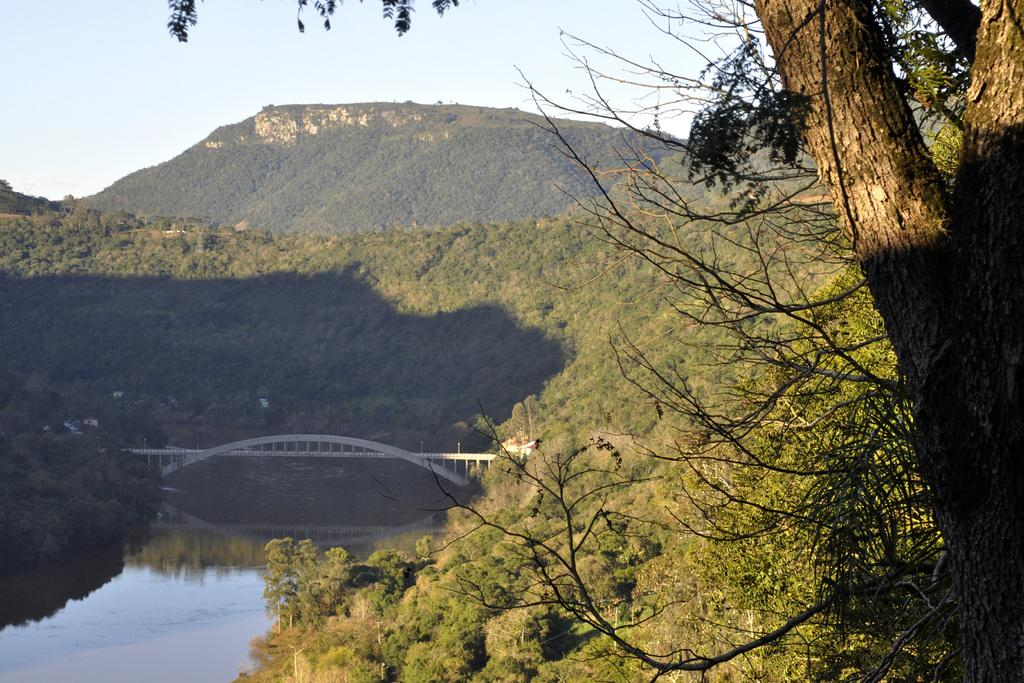What type of landscape is depicted in the image? The image features hills and trees. What man-made structure can be seen in the image? There is a bridge in the image. What natural element is visible in the image? Water is visible in the image. What part of the natural environment is visible in the image? The sky is visible in the image. How many tramps are visible on the sheet in the image? There are no tramps or sheets present in the image. What type of chickens can be seen roaming around the bridge in the image? There are no chickens present in the image; it features hills, trees, a bridge, water, and the sky. 